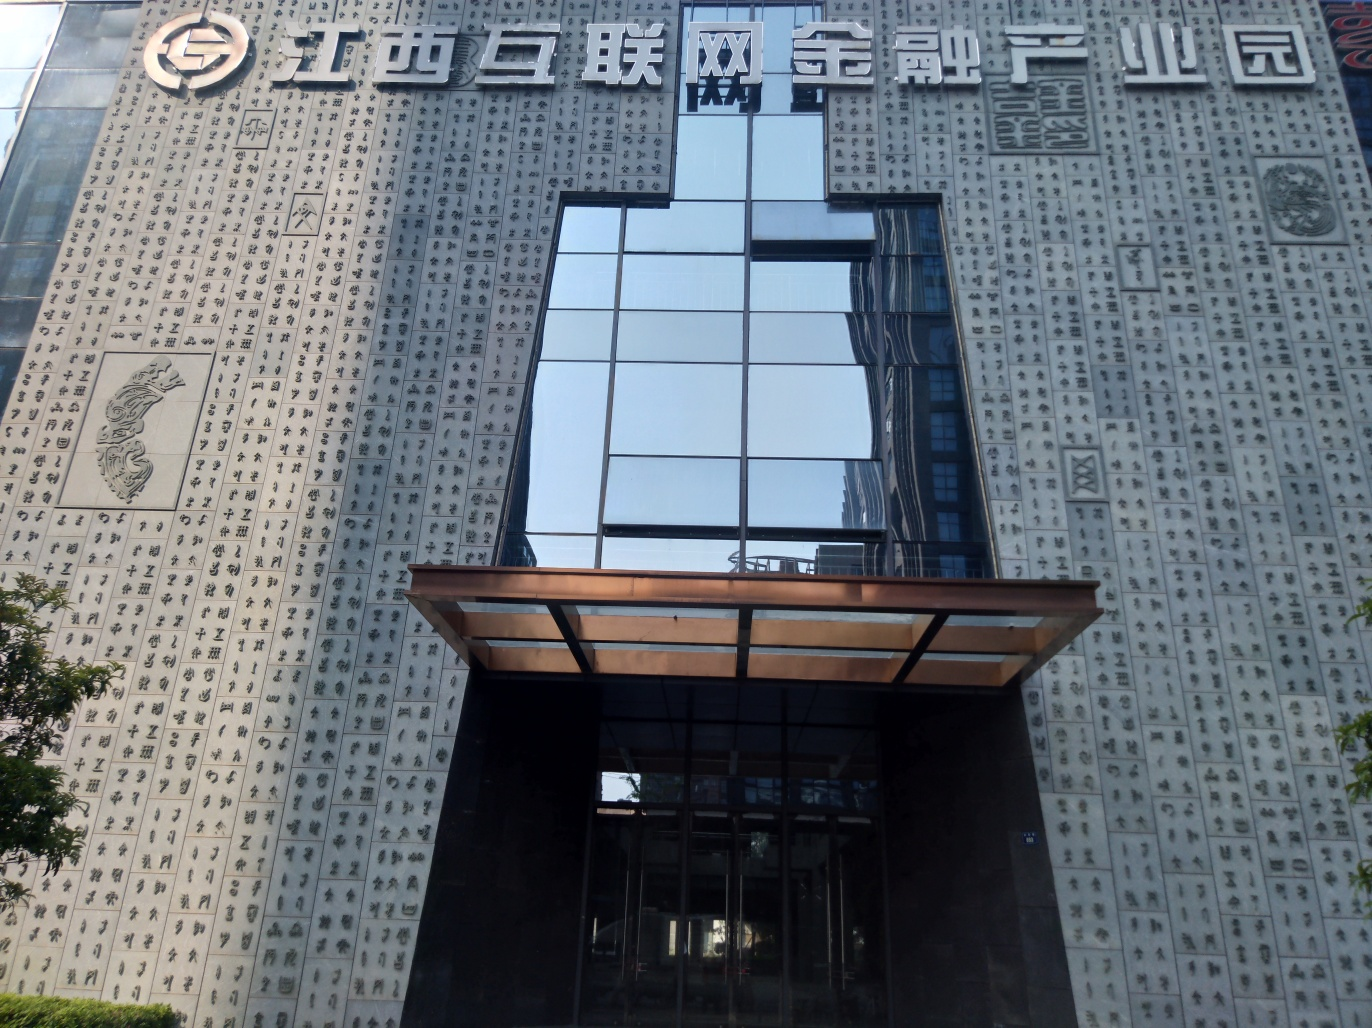What do the Chinese characters on the building signify? The Chinese characters represent an intriguing fusion of art and language, possibly symbolizing the building's purpose or the values of the institution housed within. Is there any symbolism behind the dragon emblem on the wall? Typically, dragons in Chinese culture symbolize power, strength, and good fortune. Seeing one on a building could indicate a prestigious or influential establishment. 